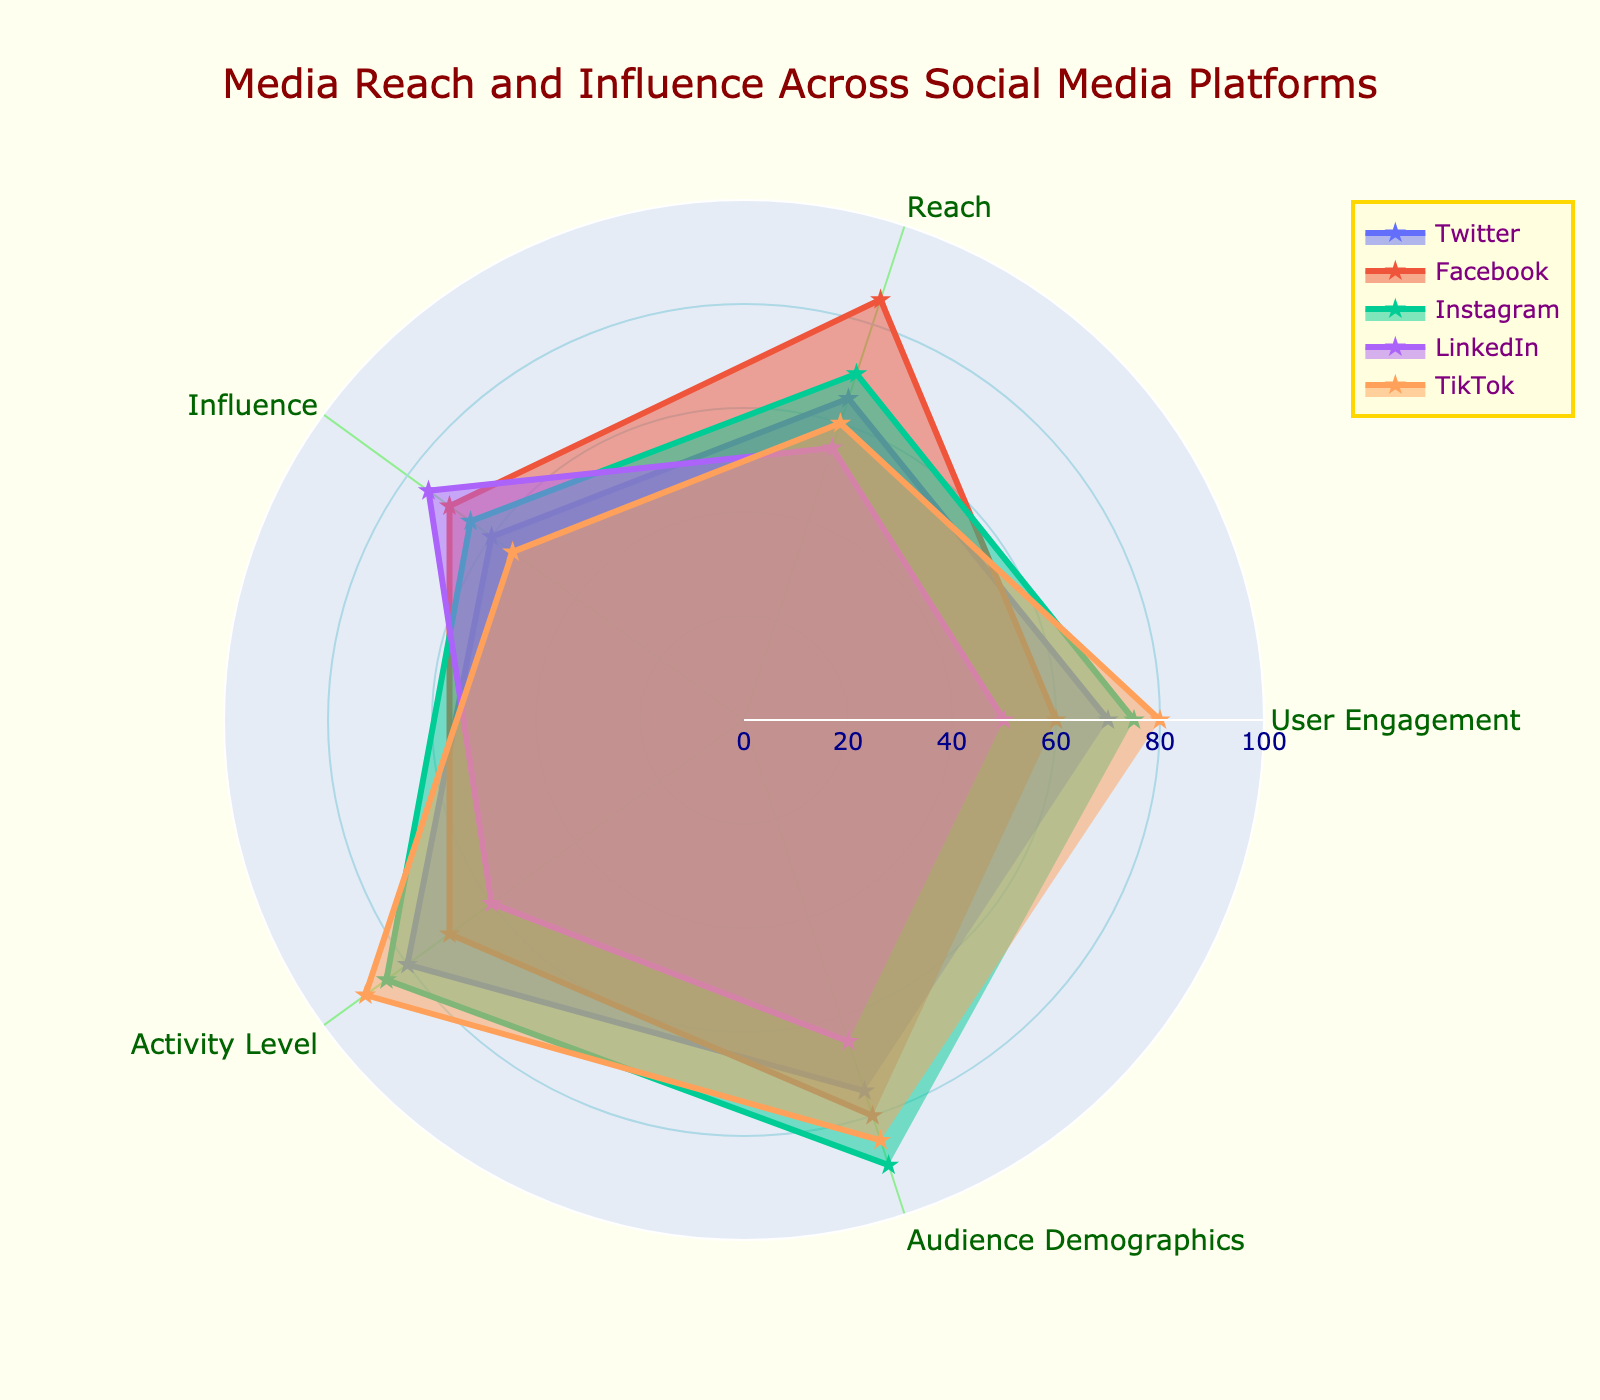What's the title of the figure? The title of the figure can be found at the top, usually in larger, bold font compared to other texts.
Answer: Media Reach and Influence Across Social Media Platforms Which platform has the highest activity level? The highest activity level is represented by the largest value in the 'Activity Level' category, which is shown by the extension of the radar chart section towards 90.
Answer: TikTok What are the two platforms with the highest audience demographics score? By looking at the 'Audience Demographics' category, the platforms with the highest extensions toward 90 are Instagram and TikTok.
Answer: Instagram and TikTok Which platform has the lowest engagement, and what is its value? The lowest engagement is indicated by the shortest extension in the 'User Engagement' category. LinkedIn has a user engagement value of 50.
Answer: LinkedIn, 50 Calculate the average "Influence" score across all platforms. The influence scores for the platforms are 60, 70, 65, 75, and 55. Adding these gives 325, and the average is 325/5 = 65.
Answer: 65 Which two platforms have the most significant difference in their "Reach" values, and what is the difference? The platforms with the highest reach values are Facebook (85) and LinkedIn (55). The difference between these values is 85 - 55 = 30.
Answer: Facebook and LinkedIn, 30 Compare the 'Reach' and 'User Engagement' values of Twitter. Which is higher and by how much? For Twitter, the 'Reach' value is 65 and the 'User Engagement' value is 70. The difference is 70 - 65 = 5, so 'User Engagement' is higher by 5 points.
Answer: User Engagement, 5 What is the median 'Activity Level' across all platforms? The 'Activity Level' scores are 80, 70, 85, 60, 90. Ordering these gives 60, 70, 80, 85, 90, and the median is the middle value, which is 80.
Answer: 80 Which platform has the most balanced scores across all categories, and what does it mean for media strategies? Balance can be observed by looking at how evenly extended the radar plot is across categories. Twitter has relatively balanced scores (70, 65, 60, 80, 75). Balancing implies that strategies can be uniformly optimized across all attributes without specific weaknesses.
Answer: Twitter, balanced overall 